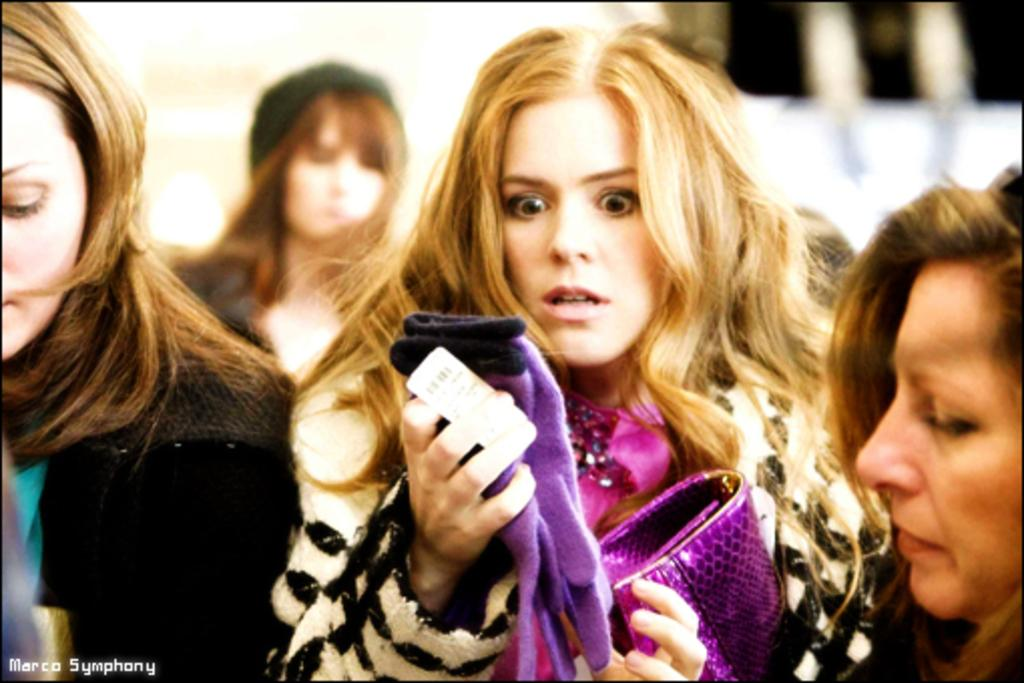Who or what can be seen in the front of the image? There are people in the front of the image. What structure is visible in the background of the image? There is a house in the background of the image. What does the mother believe about the house in the image? There is no mention of a mother or any beliefs in the image, so we cannot answer this question. 